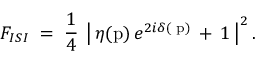<formula> <loc_0><loc_0><loc_500><loc_500>F _ { I S I } \, = \, \frac { 1 } { 4 } \, \left | \, \eta ( p ) \, e ^ { 2 i \delta ( p ) } \, + \, 1 \, \right | ^ { 2 } .</formula> 